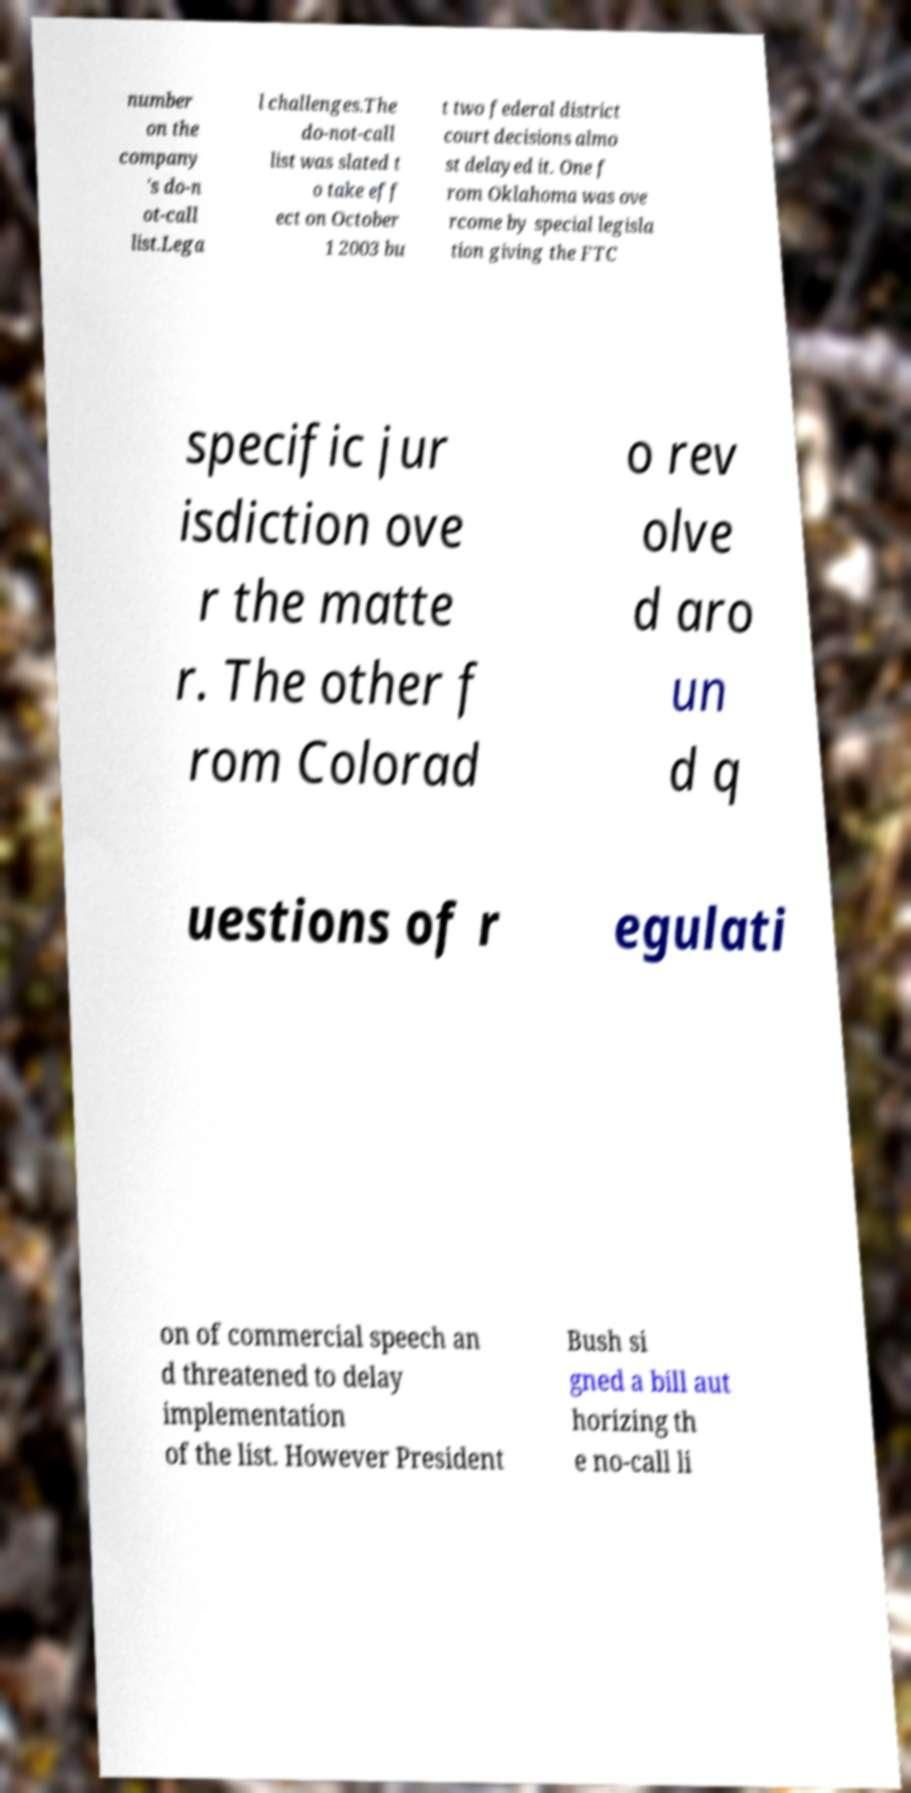I need the written content from this picture converted into text. Can you do that? number on the company 's do-n ot-call list.Lega l challenges.The do-not-call list was slated t o take eff ect on October 1 2003 bu t two federal district court decisions almo st delayed it. One f rom Oklahoma was ove rcome by special legisla tion giving the FTC specific jur isdiction ove r the matte r. The other f rom Colorad o rev olve d aro un d q uestions of r egulati on of commercial speech an d threatened to delay implementation of the list. However President Bush si gned a bill aut horizing th e no-call li 